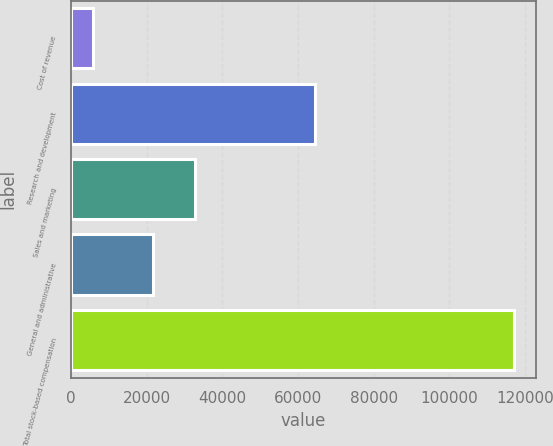Convert chart to OTSL. <chart><loc_0><loc_0><loc_500><loc_500><bar_chart><fcel>Cost of revenue<fcel>Research and development<fcel>Sales and marketing<fcel>General and administrative<fcel>Total stock-based compensation<nl><fcel>5952<fcel>64386<fcel>32674.5<fcel>21570<fcel>116997<nl></chart> 